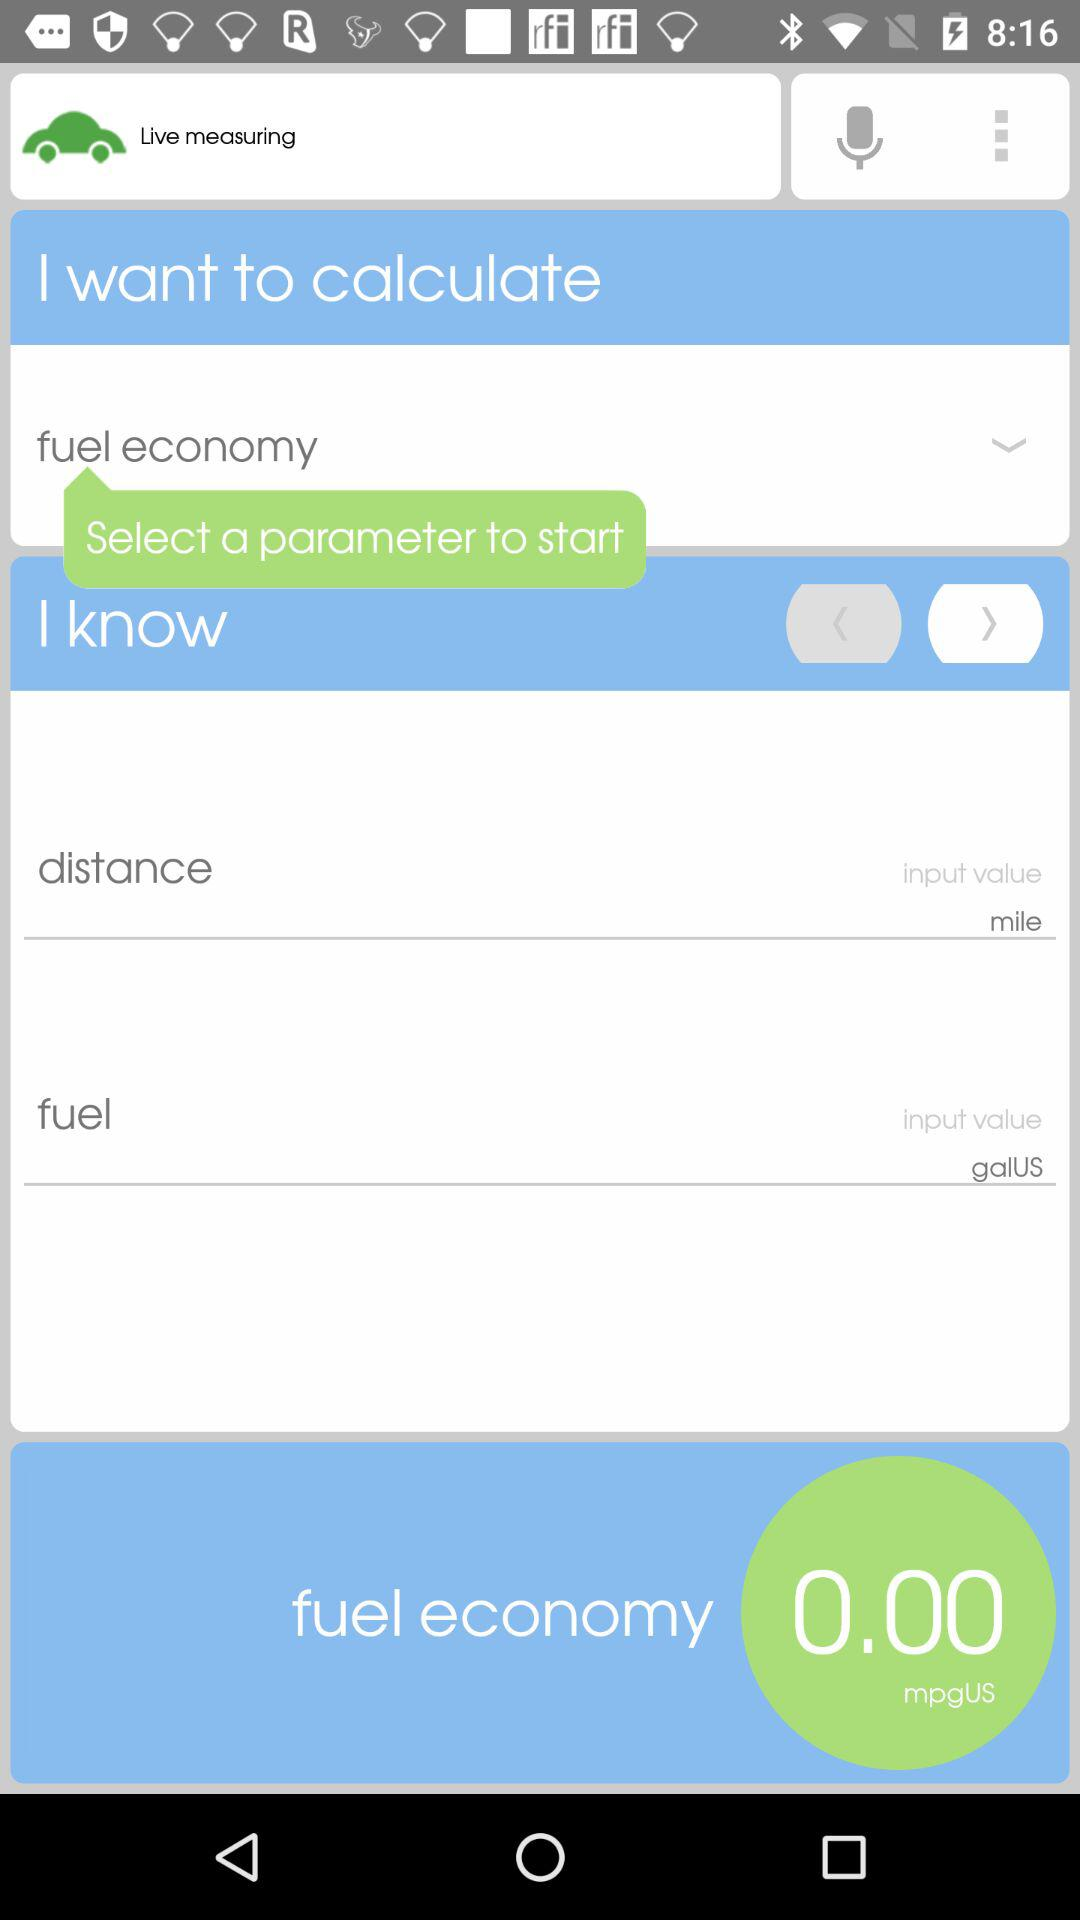What is the value of the fuel economy? The value of fuel economy is 0.0 mpg US. 